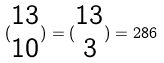<formula> <loc_0><loc_0><loc_500><loc_500>( \begin{matrix} 1 3 \\ 1 0 \end{matrix} ) = ( \begin{matrix} 1 3 \\ 3 \end{matrix} ) = 2 8 6</formula> 